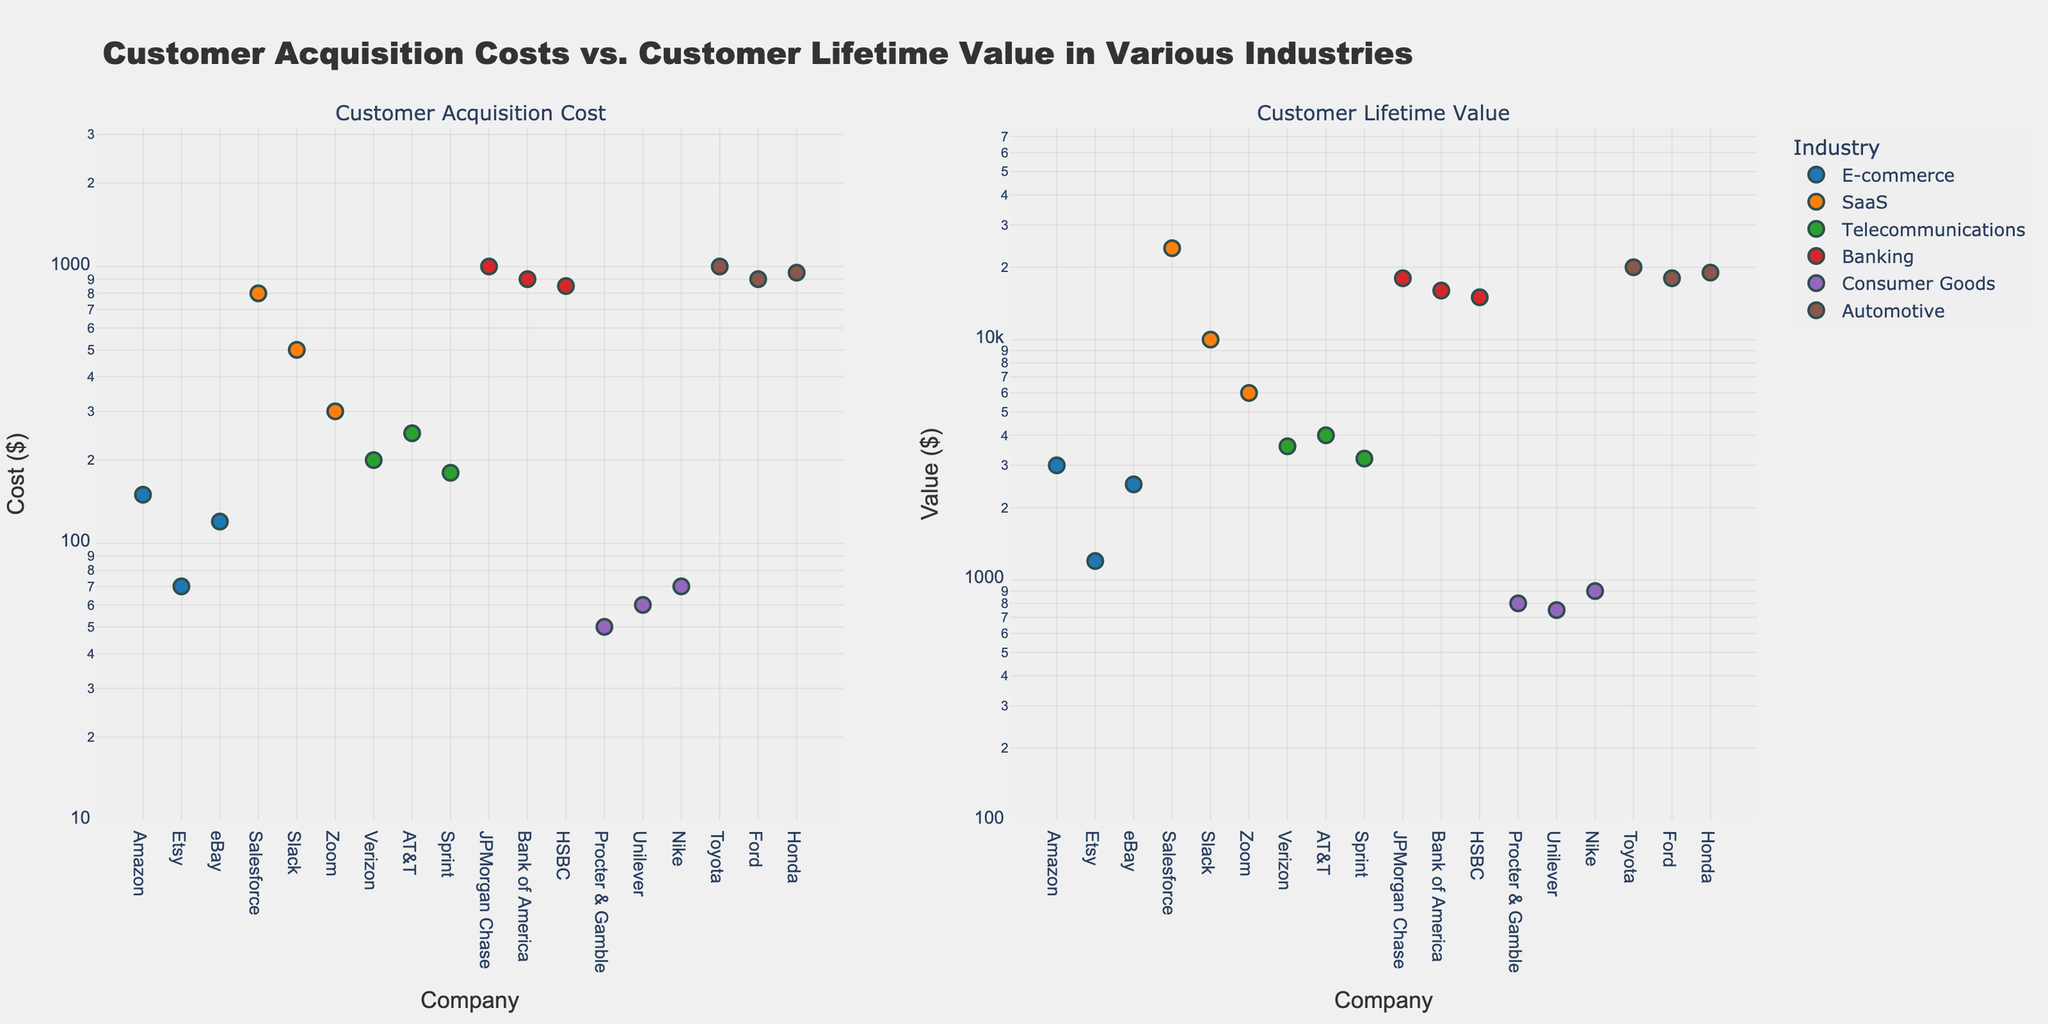What is the title of the figure? The title is displayed prominently at the top of the figure. It summarizes the focus of the subplots.
Answer: "Customer Acquisition Costs vs. Customer Lifetime Value in Various Industries" Which industry has the highest customer acquisition cost? We need to find the highest point on the y-axis in the left subplot, corresponding to the industry label. The highest value is $1000, under Automotive (Toyota).
Answer: Automotive Which company in SaaS has the highest customer lifetime value? Within the right subplot, look for the highest data point under the SaaS label, which corresponds to Salesforce.
Answer: Salesforce Compare the customer acquisition cost of Verizon and Sprint. Which is higher? Identify Verizon and Sprint in the left subplot and compare their corresponding y-values. Verizon has $200, and Sprint has $180.
Answer: Verizon What is the ratio of customer lifetime value to customer acquisition cost in Banking for JPMorgan Chase? Locate JPMorgan Chase in both subplots. The values are $18000 (lifetime value) and $1000 (acquisition cost). The ratio is 18000 / 1000.
Answer: 18 Which industry has the smallest range of customer acquisition costs? We observe and compare the spread of data points in the left subplot for each industry. Consumer Goods shows the smallest range, with values between $50 and $70.
Answer: Consumer Goods How does the customer lifetime value for Ford compare to that for Toyota? In the right subplot, compare the y-values for Ford and Toyota. Both have $18000 (Ford) and $20000 (Toyota) respectively, Toyota is higher.
Answer: Toyota is higher Which company in the E-commerce industry has the lowest customer acquisition cost? In the left subplot, compare the data points for Amazon, Etsy, and eBay under E-commerce. The lowest value is $70, for Etsy.
Answer: Etsy What is the median customer acquisition cost for the Telecommunications industry? For Verizon ($200), AT&T ($250), and Sprint ($180), sort and find the middle value. The median is $200.
Answer: $200 Are customer acquisition costs or customer lifetime values generally higher? Comparing the scales of both subplots, customer lifetime values are generally higher on the logarithmic y-axis.
Answer: Customer lifetime values 